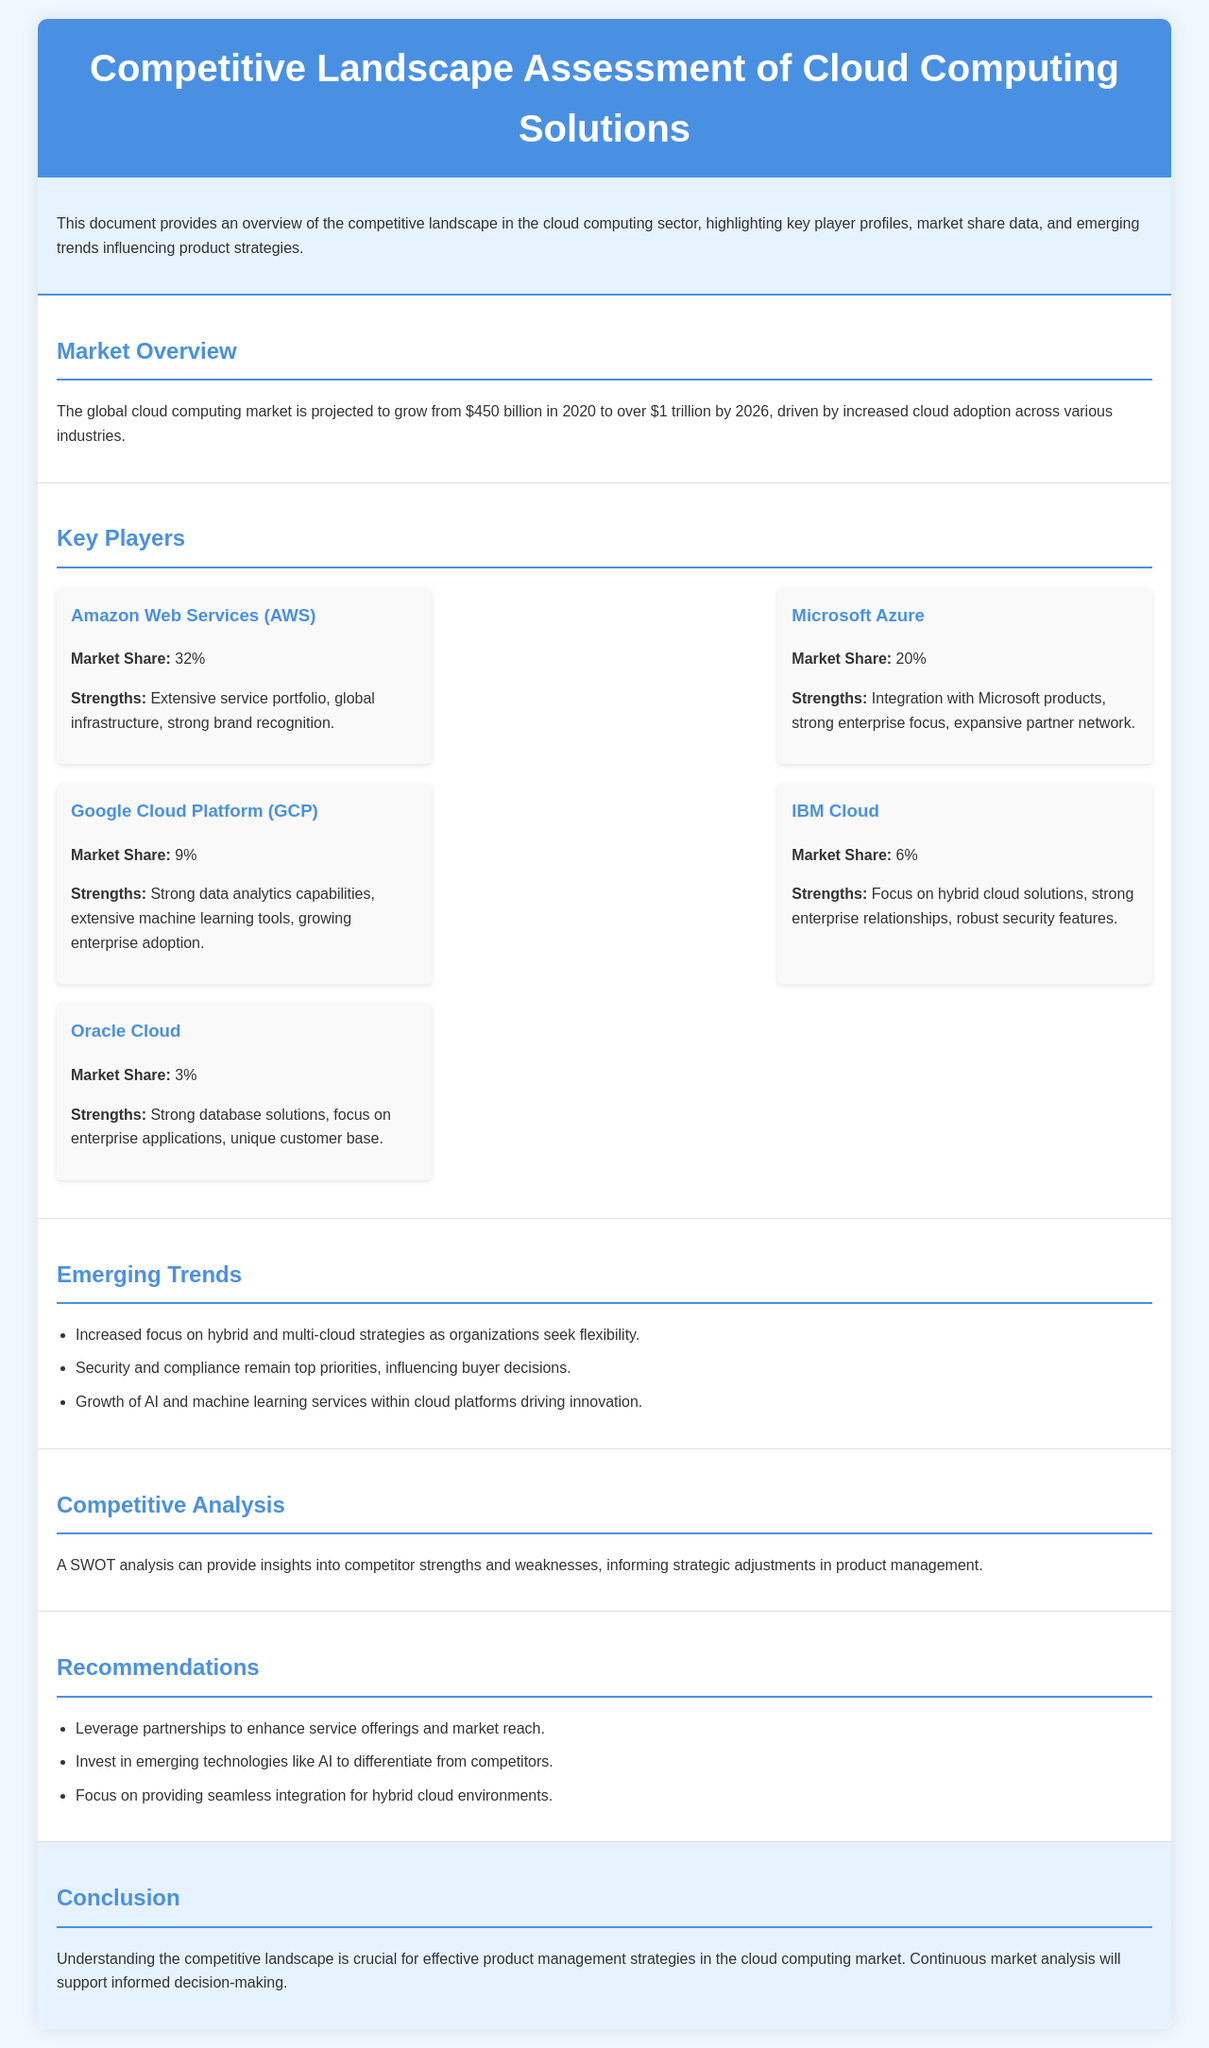What is the projected market size in 2026? The document states that the global cloud computing market is projected to grow to over $1 trillion by 2026.
Answer: Over $1 trillion What is the market share of Microsoft Azure? The market share of Microsoft Azure is mentioned specifically in the key players section.
Answer: 20% Which cloud provider specializes in hybrid cloud solutions? The document highlights IBM Cloud for its focus on hybrid cloud solutions.
Answer: IBM Cloud What are the three strengths of Amazon Web Services? The strengths of AWS are listed as an extensive service portfolio, global infrastructure, and strong brand recognition.
Answer: Extensive service portfolio, global infrastructure, strong brand recognition What trend influences buyer decisions according to the document? The document mentions security and compliance as top priorities influencing buyer decisions.
Answer: Security and compliance How many key players are listed in the document? The document explicitly lists five key players in the cloud computing market.
Answer: Five What recommendation involves partnerships? The recommendation regarding enhancing service offerings and market reach is about leveraging partnerships.
Answer: Leverage partnerships Which cloud provider has the highest market share? The document clearly states the market share percentages for each provider, with AWS having the highest.
Answer: Amazon Web Services (AWS) 